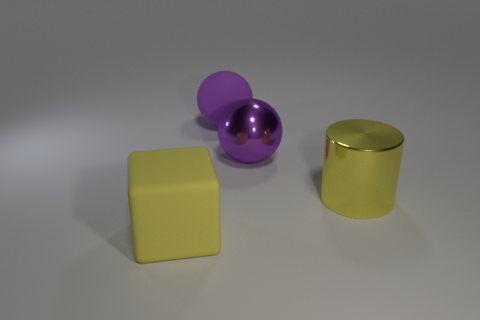Subtract 1 blocks. How many blocks are left? 0 Subtract all cubes. How many objects are left? 3 Subtract all purple cylinders. Subtract all cyan blocks. How many cylinders are left? 1 Subtract all big metallic spheres. Subtract all large yellow rubber blocks. How many objects are left? 2 Add 2 purple spheres. How many purple spheres are left? 4 Add 3 big purple shiny balls. How many big purple shiny balls exist? 4 Add 4 tiny gray metallic spheres. How many objects exist? 8 Subtract 0 green blocks. How many objects are left? 4 